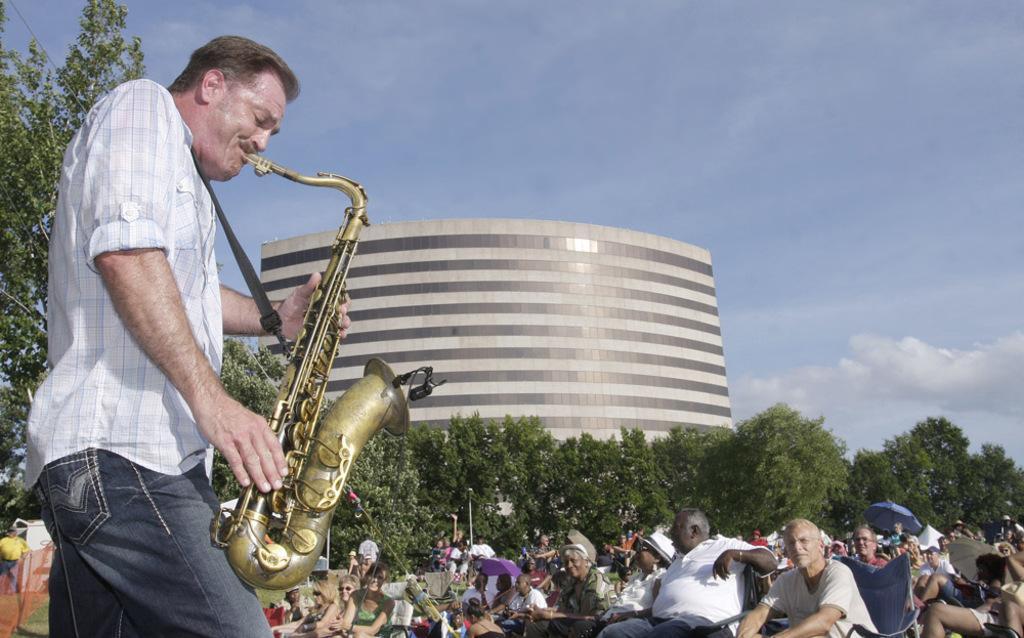In one or two sentences, can you explain what this image depicts? In this image we can see this person wearing shirt is playing saxophone and standing here. In the background, we can see a few more people sitting on the chairs, trees, buildings and the sky with clouds. 